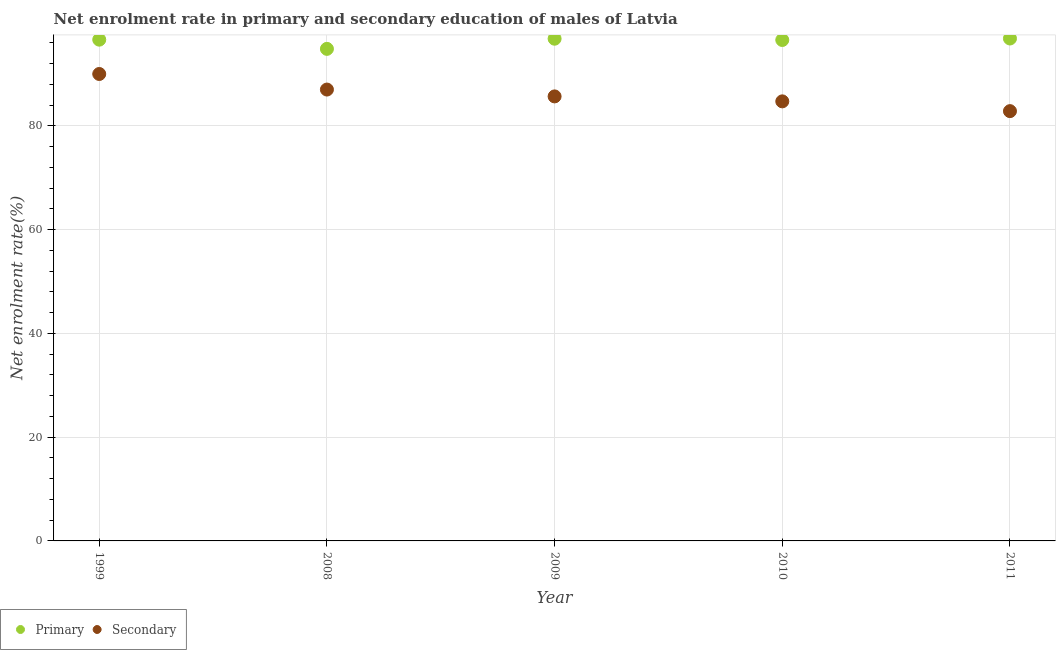How many different coloured dotlines are there?
Provide a short and direct response. 2. What is the enrollment rate in secondary education in 1999?
Provide a succinct answer. 90.02. Across all years, what is the maximum enrollment rate in secondary education?
Keep it short and to the point. 90.02. Across all years, what is the minimum enrollment rate in secondary education?
Offer a very short reply. 82.86. In which year was the enrollment rate in secondary education maximum?
Provide a short and direct response. 1999. What is the total enrollment rate in secondary education in the graph?
Provide a short and direct response. 430.35. What is the difference between the enrollment rate in primary education in 2008 and that in 2010?
Ensure brevity in your answer.  -1.71. What is the difference between the enrollment rate in secondary education in 2011 and the enrollment rate in primary education in 1999?
Keep it short and to the point. -13.78. What is the average enrollment rate in primary education per year?
Offer a terse response. 96.35. In the year 2009, what is the difference between the enrollment rate in primary education and enrollment rate in secondary education?
Ensure brevity in your answer.  11.12. In how many years, is the enrollment rate in primary education greater than 80 %?
Your answer should be very brief. 5. What is the ratio of the enrollment rate in primary education in 2009 to that in 2010?
Provide a short and direct response. 1. Is the difference between the enrollment rate in primary education in 2009 and 2010 greater than the difference between the enrollment rate in secondary education in 2009 and 2010?
Your response must be concise. No. What is the difference between the highest and the second highest enrollment rate in primary education?
Provide a succinct answer. 0.04. What is the difference between the highest and the lowest enrollment rate in primary education?
Offer a terse response. 2. How many years are there in the graph?
Ensure brevity in your answer.  5. Are the values on the major ticks of Y-axis written in scientific E-notation?
Give a very brief answer. No. Does the graph contain any zero values?
Offer a very short reply. No. Does the graph contain grids?
Ensure brevity in your answer.  Yes. Where does the legend appear in the graph?
Make the answer very short. Bottom left. How are the legend labels stacked?
Make the answer very short. Horizontal. What is the title of the graph?
Give a very brief answer. Net enrolment rate in primary and secondary education of males of Latvia. What is the label or title of the Y-axis?
Provide a succinct answer. Net enrolment rate(%). What is the Net enrolment rate(%) in Primary in 1999?
Provide a short and direct response. 96.64. What is the Net enrolment rate(%) of Secondary in 1999?
Your answer should be very brief. 90.02. What is the Net enrolment rate(%) of Primary in 2008?
Offer a very short reply. 94.87. What is the Net enrolment rate(%) in Secondary in 2008?
Keep it short and to the point. 87.02. What is the Net enrolment rate(%) of Primary in 2009?
Give a very brief answer. 96.82. What is the Net enrolment rate(%) of Secondary in 2009?
Give a very brief answer. 85.7. What is the Net enrolment rate(%) in Primary in 2010?
Offer a terse response. 96.58. What is the Net enrolment rate(%) of Secondary in 2010?
Provide a short and direct response. 84.74. What is the Net enrolment rate(%) of Primary in 2011?
Your response must be concise. 96.86. What is the Net enrolment rate(%) in Secondary in 2011?
Your response must be concise. 82.86. Across all years, what is the maximum Net enrolment rate(%) in Primary?
Ensure brevity in your answer.  96.86. Across all years, what is the maximum Net enrolment rate(%) in Secondary?
Your answer should be compact. 90.02. Across all years, what is the minimum Net enrolment rate(%) in Primary?
Keep it short and to the point. 94.87. Across all years, what is the minimum Net enrolment rate(%) in Secondary?
Offer a terse response. 82.86. What is the total Net enrolment rate(%) of Primary in the graph?
Offer a terse response. 481.77. What is the total Net enrolment rate(%) of Secondary in the graph?
Offer a very short reply. 430.35. What is the difference between the Net enrolment rate(%) of Primary in 1999 and that in 2008?
Provide a succinct answer. 1.77. What is the difference between the Net enrolment rate(%) of Secondary in 1999 and that in 2008?
Keep it short and to the point. 3. What is the difference between the Net enrolment rate(%) in Primary in 1999 and that in 2009?
Offer a very short reply. -0.18. What is the difference between the Net enrolment rate(%) of Secondary in 1999 and that in 2009?
Provide a short and direct response. 4.32. What is the difference between the Net enrolment rate(%) in Primary in 1999 and that in 2010?
Your response must be concise. 0.06. What is the difference between the Net enrolment rate(%) of Secondary in 1999 and that in 2010?
Keep it short and to the point. 5.28. What is the difference between the Net enrolment rate(%) in Primary in 1999 and that in 2011?
Your answer should be very brief. -0.22. What is the difference between the Net enrolment rate(%) of Secondary in 1999 and that in 2011?
Provide a succinct answer. 7.16. What is the difference between the Net enrolment rate(%) in Primary in 2008 and that in 2009?
Ensure brevity in your answer.  -1.96. What is the difference between the Net enrolment rate(%) in Secondary in 2008 and that in 2009?
Make the answer very short. 1.32. What is the difference between the Net enrolment rate(%) in Primary in 2008 and that in 2010?
Give a very brief answer. -1.71. What is the difference between the Net enrolment rate(%) in Secondary in 2008 and that in 2010?
Your response must be concise. 2.28. What is the difference between the Net enrolment rate(%) in Primary in 2008 and that in 2011?
Ensure brevity in your answer.  -2. What is the difference between the Net enrolment rate(%) of Secondary in 2008 and that in 2011?
Your response must be concise. 4.16. What is the difference between the Net enrolment rate(%) in Primary in 2009 and that in 2010?
Ensure brevity in your answer.  0.25. What is the difference between the Net enrolment rate(%) of Secondary in 2009 and that in 2010?
Keep it short and to the point. 0.96. What is the difference between the Net enrolment rate(%) of Primary in 2009 and that in 2011?
Provide a short and direct response. -0.04. What is the difference between the Net enrolment rate(%) in Secondary in 2009 and that in 2011?
Your response must be concise. 2.84. What is the difference between the Net enrolment rate(%) of Primary in 2010 and that in 2011?
Provide a short and direct response. -0.29. What is the difference between the Net enrolment rate(%) in Secondary in 2010 and that in 2011?
Provide a succinct answer. 1.88. What is the difference between the Net enrolment rate(%) in Primary in 1999 and the Net enrolment rate(%) in Secondary in 2008?
Give a very brief answer. 9.62. What is the difference between the Net enrolment rate(%) in Primary in 1999 and the Net enrolment rate(%) in Secondary in 2009?
Provide a succinct answer. 10.94. What is the difference between the Net enrolment rate(%) of Primary in 1999 and the Net enrolment rate(%) of Secondary in 2010?
Keep it short and to the point. 11.9. What is the difference between the Net enrolment rate(%) in Primary in 1999 and the Net enrolment rate(%) in Secondary in 2011?
Your response must be concise. 13.78. What is the difference between the Net enrolment rate(%) in Primary in 2008 and the Net enrolment rate(%) in Secondary in 2009?
Your answer should be compact. 9.17. What is the difference between the Net enrolment rate(%) of Primary in 2008 and the Net enrolment rate(%) of Secondary in 2010?
Offer a very short reply. 10.12. What is the difference between the Net enrolment rate(%) in Primary in 2008 and the Net enrolment rate(%) in Secondary in 2011?
Make the answer very short. 12.01. What is the difference between the Net enrolment rate(%) of Primary in 2009 and the Net enrolment rate(%) of Secondary in 2010?
Give a very brief answer. 12.08. What is the difference between the Net enrolment rate(%) in Primary in 2009 and the Net enrolment rate(%) in Secondary in 2011?
Your answer should be very brief. 13.96. What is the difference between the Net enrolment rate(%) of Primary in 2010 and the Net enrolment rate(%) of Secondary in 2011?
Your answer should be very brief. 13.72. What is the average Net enrolment rate(%) in Primary per year?
Offer a terse response. 96.35. What is the average Net enrolment rate(%) in Secondary per year?
Make the answer very short. 86.07. In the year 1999, what is the difference between the Net enrolment rate(%) in Primary and Net enrolment rate(%) in Secondary?
Your response must be concise. 6.62. In the year 2008, what is the difference between the Net enrolment rate(%) in Primary and Net enrolment rate(%) in Secondary?
Provide a short and direct response. 7.85. In the year 2009, what is the difference between the Net enrolment rate(%) in Primary and Net enrolment rate(%) in Secondary?
Provide a short and direct response. 11.12. In the year 2010, what is the difference between the Net enrolment rate(%) of Primary and Net enrolment rate(%) of Secondary?
Offer a terse response. 11.83. In the year 2011, what is the difference between the Net enrolment rate(%) in Primary and Net enrolment rate(%) in Secondary?
Provide a short and direct response. 14. What is the ratio of the Net enrolment rate(%) in Primary in 1999 to that in 2008?
Make the answer very short. 1.02. What is the ratio of the Net enrolment rate(%) in Secondary in 1999 to that in 2008?
Offer a terse response. 1.03. What is the ratio of the Net enrolment rate(%) in Secondary in 1999 to that in 2009?
Give a very brief answer. 1.05. What is the ratio of the Net enrolment rate(%) of Primary in 1999 to that in 2010?
Keep it short and to the point. 1. What is the ratio of the Net enrolment rate(%) in Secondary in 1999 to that in 2010?
Make the answer very short. 1.06. What is the ratio of the Net enrolment rate(%) in Primary in 1999 to that in 2011?
Your response must be concise. 1. What is the ratio of the Net enrolment rate(%) in Secondary in 1999 to that in 2011?
Provide a succinct answer. 1.09. What is the ratio of the Net enrolment rate(%) of Primary in 2008 to that in 2009?
Your answer should be very brief. 0.98. What is the ratio of the Net enrolment rate(%) of Secondary in 2008 to that in 2009?
Your response must be concise. 1.02. What is the ratio of the Net enrolment rate(%) in Primary in 2008 to that in 2010?
Offer a very short reply. 0.98. What is the ratio of the Net enrolment rate(%) in Secondary in 2008 to that in 2010?
Keep it short and to the point. 1.03. What is the ratio of the Net enrolment rate(%) in Primary in 2008 to that in 2011?
Ensure brevity in your answer.  0.98. What is the ratio of the Net enrolment rate(%) in Secondary in 2008 to that in 2011?
Provide a succinct answer. 1.05. What is the ratio of the Net enrolment rate(%) in Primary in 2009 to that in 2010?
Your response must be concise. 1. What is the ratio of the Net enrolment rate(%) of Secondary in 2009 to that in 2010?
Make the answer very short. 1.01. What is the ratio of the Net enrolment rate(%) in Primary in 2009 to that in 2011?
Make the answer very short. 1. What is the ratio of the Net enrolment rate(%) in Secondary in 2009 to that in 2011?
Provide a succinct answer. 1.03. What is the ratio of the Net enrolment rate(%) in Primary in 2010 to that in 2011?
Your answer should be very brief. 1. What is the ratio of the Net enrolment rate(%) of Secondary in 2010 to that in 2011?
Keep it short and to the point. 1.02. What is the difference between the highest and the second highest Net enrolment rate(%) of Primary?
Make the answer very short. 0.04. What is the difference between the highest and the second highest Net enrolment rate(%) of Secondary?
Your answer should be compact. 3. What is the difference between the highest and the lowest Net enrolment rate(%) of Primary?
Your answer should be compact. 2. What is the difference between the highest and the lowest Net enrolment rate(%) in Secondary?
Provide a short and direct response. 7.16. 